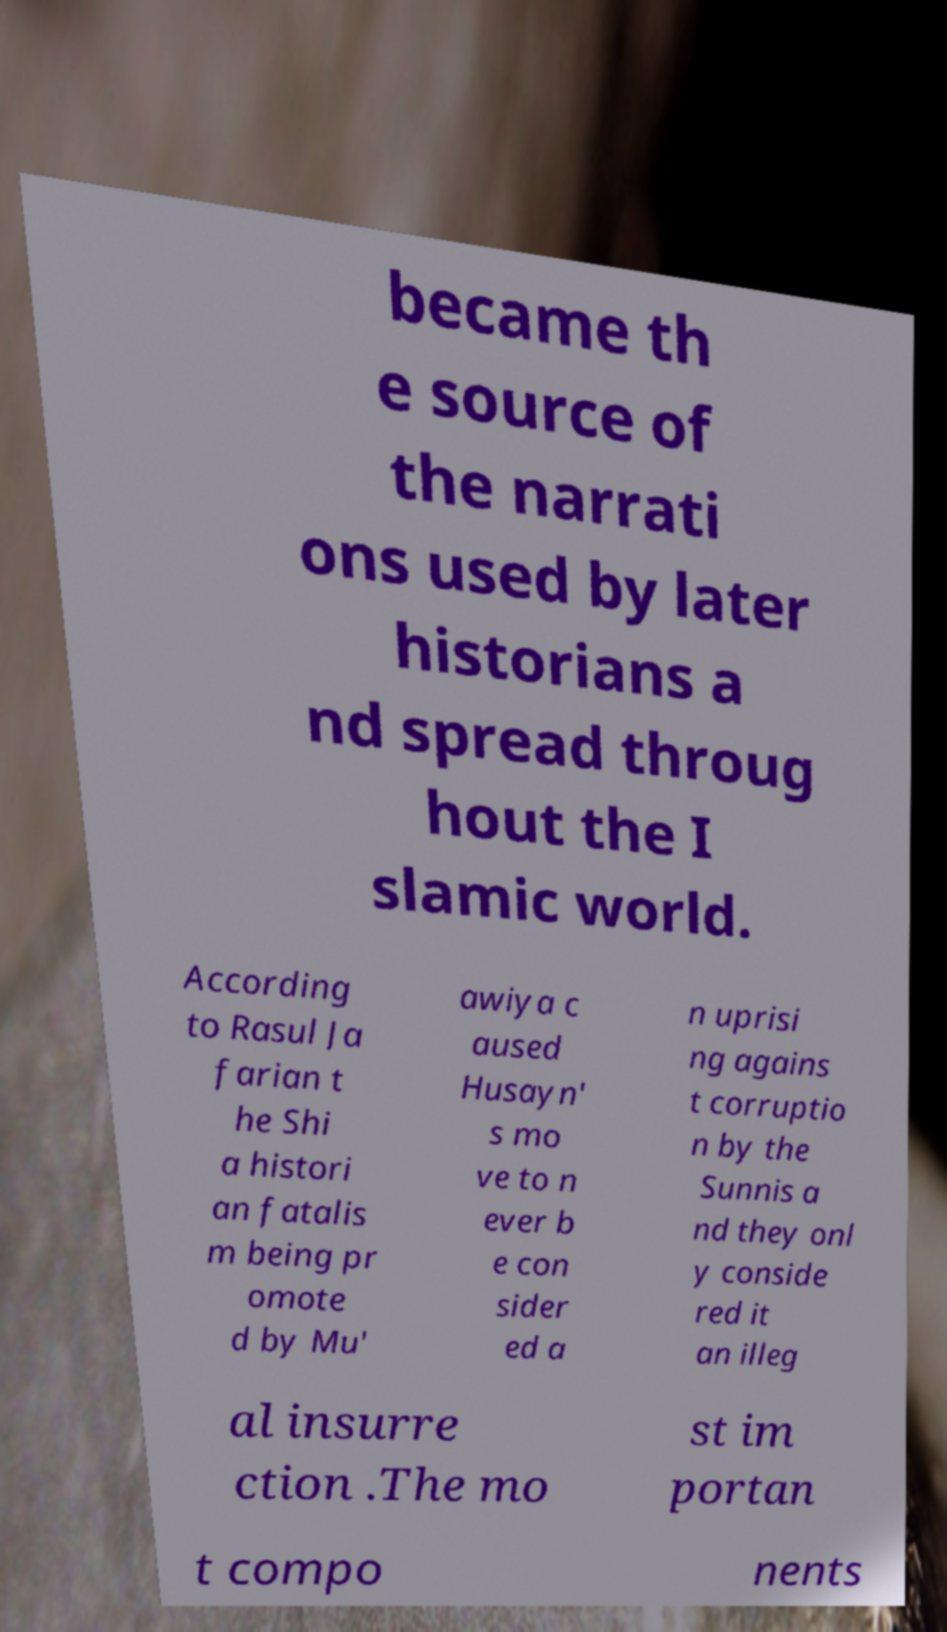I need the written content from this picture converted into text. Can you do that? became th e source of the narrati ons used by later historians a nd spread throug hout the I slamic world. According to Rasul Ja farian t he Shi a histori an fatalis m being pr omote d by Mu' awiya c aused Husayn' s mo ve to n ever b e con sider ed a n uprisi ng agains t corruptio n by the Sunnis a nd they onl y conside red it an illeg al insurre ction .The mo st im portan t compo nents 